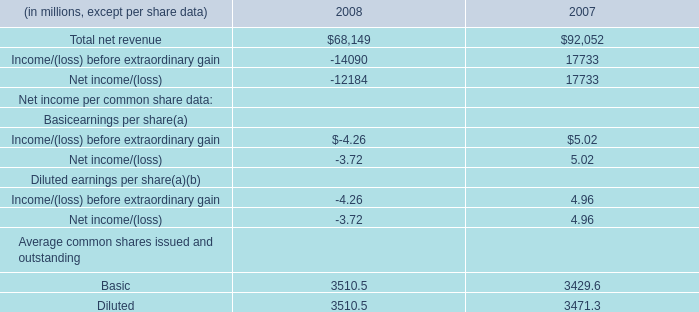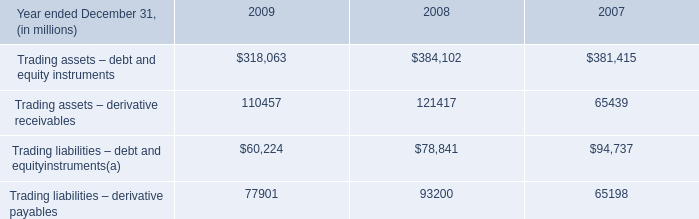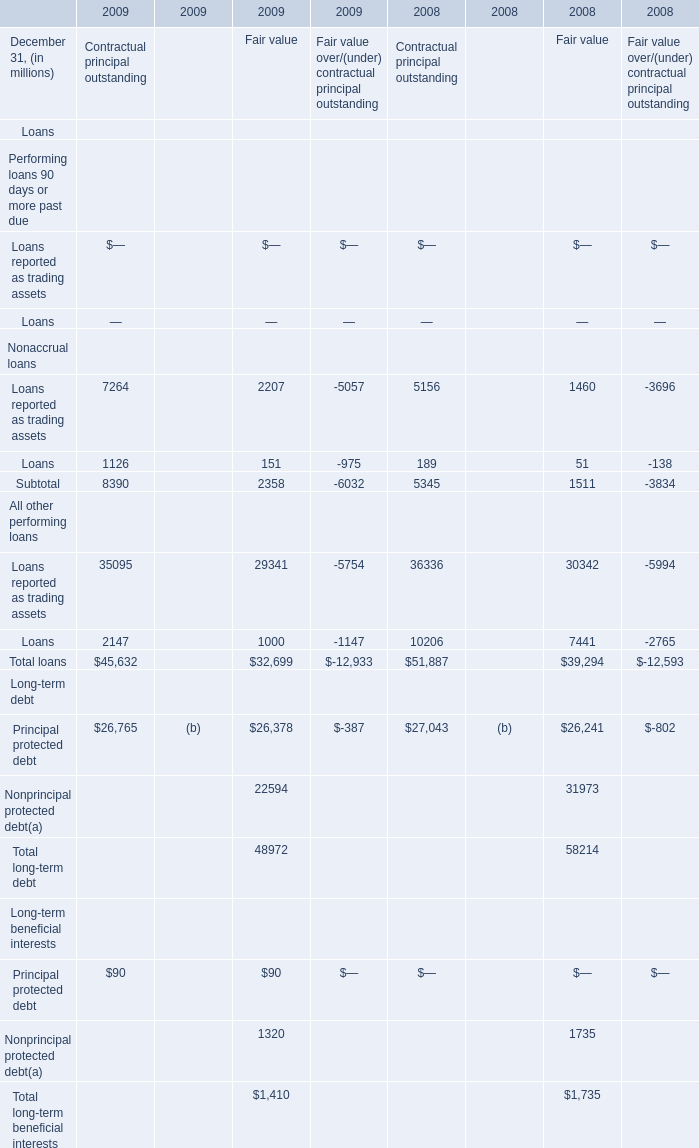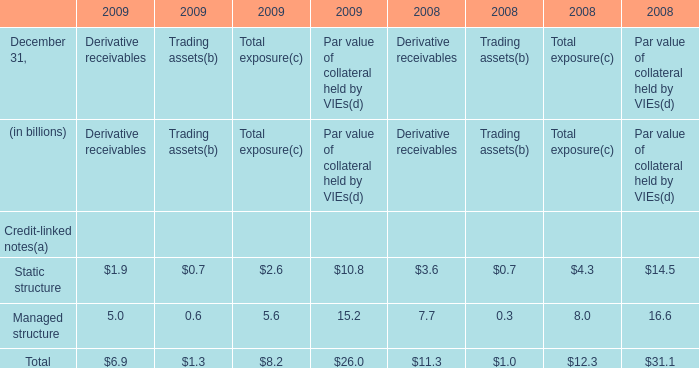what's the total amount of Trading assets – derivative receivables of 2008, and Basic Average common shares issued and outstanding of 2008 ? 
Computations: (121417.0 + 3510.5)
Answer: 124927.5. 